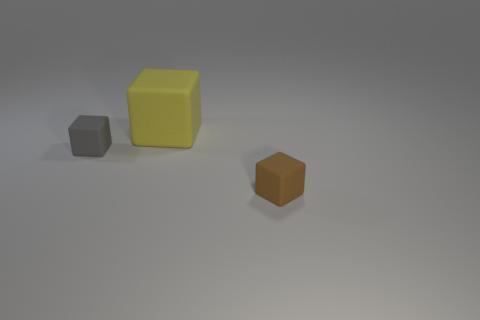What size is the brown rubber object?
Offer a very short reply. Small. There is a rubber object that is right of the tiny gray thing and left of the tiny brown block; what size is it?
Your answer should be very brief. Large. There is a large yellow thing left of the small brown block; what is its shape?
Your answer should be compact. Cube. Is the small brown object made of the same material as the cube left of the large yellow block?
Keep it short and to the point. Yes. Do the tiny gray thing and the big object have the same shape?
Provide a short and direct response. Yes. What is the material of the tiny brown thing that is the same shape as the tiny gray thing?
Your answer should be compact. Rubber. There is a block that is both on the right side of the gray matte thing and in front of the big cube; what color is it?
Keep it short and to the point. Brown. What is the color of the large rubber thing?
Keep it short and to the point. Yellow. Are there any brown objects that have the same shape as the big yellow rubber thing?
Provide a succinct answer. Yes. What is the size of the matte cube that is on the left side of the big yellow rubber thing?
Give a very brief answer. Small. 